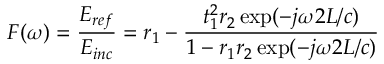<formula> <loc_0><loc_0><loc_500><loc_500>F ( \omega ) = \frac { E _ { r e f } } { E _ { i n c } } = r _ { 1 } - \frac { t _ { 1 } ^ { 2 } r _ { 2 } \exp ( - j \omega 2 L / c ) } { 1 - r _ { 1 } r _ { 2 } \exp ( - j \omega 2 L / c ) }</formula> 